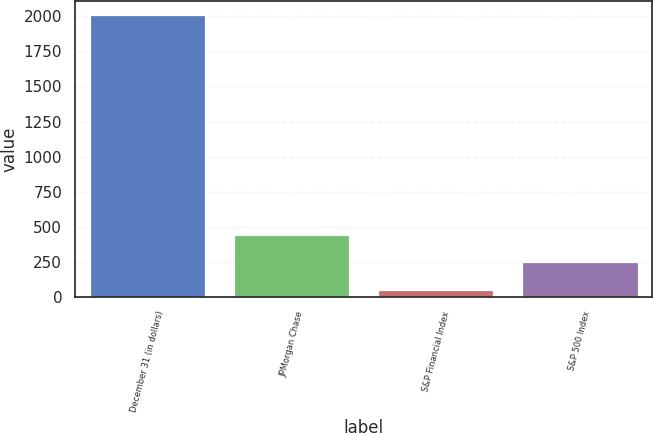<chart> <loc_0><loc_0><loc_500><loc_500><bar_chart><fcel>December 31 (in dollars)<fcel>JPMorgan Chase<fcel>S&P Financial Index<fcel>S&P 500 Index<nl><fcel>2009<fcel>442.44<fcel>50.8<fcel>246.62<nl></chart> 